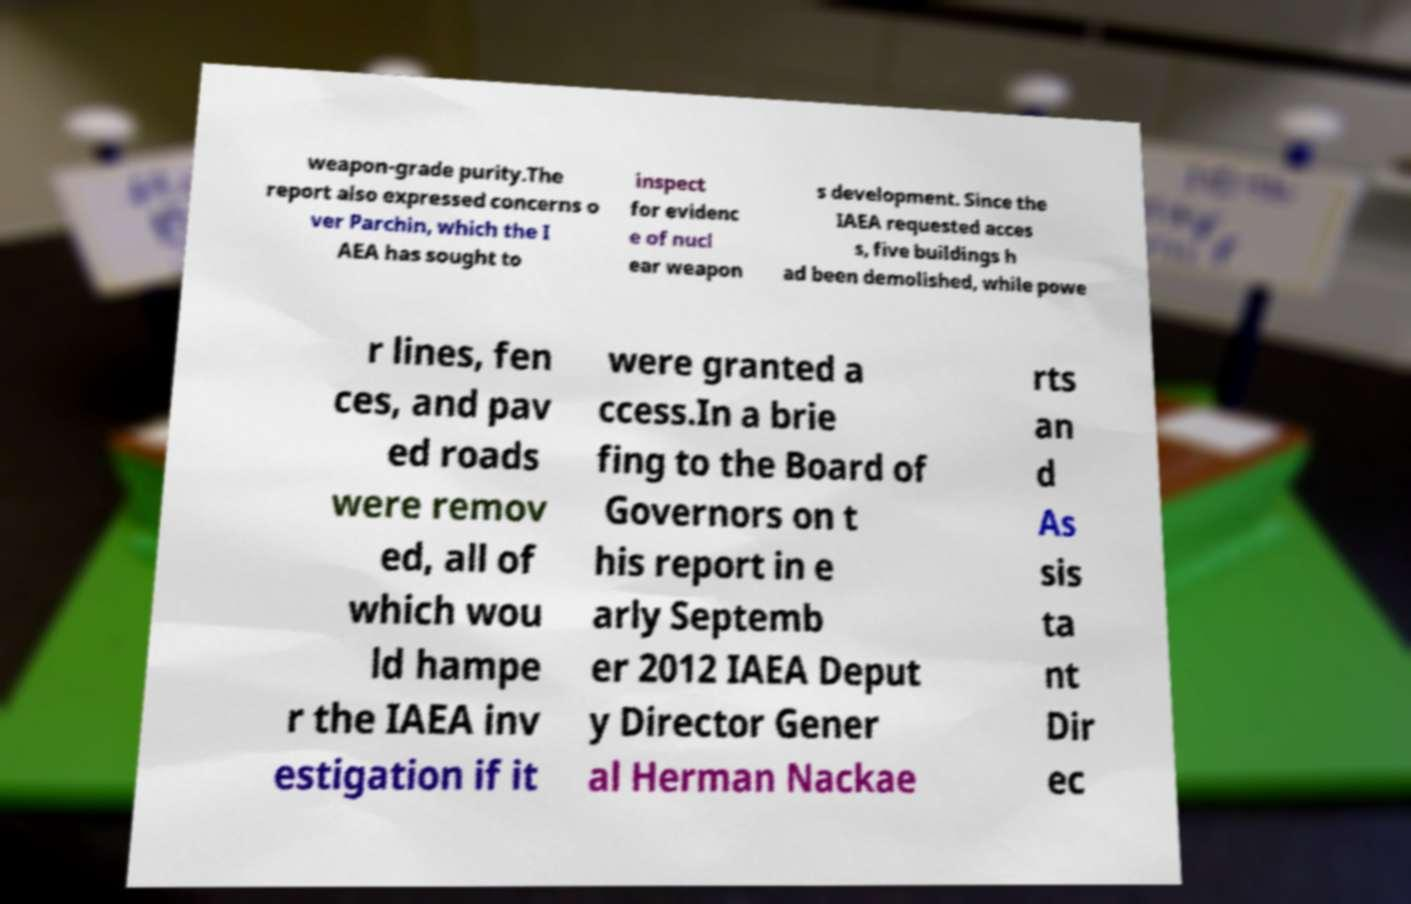Could you assist in decoding the text presented in this image and type it out clearly? weapon-grade purity.The report also expressed concerns o ver Parchin, which the I AEA has sought to inspect for evidenc e of nucl ear weapon s development. Since the IAEA requested acces s, five buildings h ad been demolished, while powe r lines, fen ces, and pav ed roads were remov ed, all of which wou ld hampe r the IAEA inv estigation if it were granted a ccess.In a brie fing to the Board of Governors on t his report in e arly Septemb er 2012 IAEA Deput y Director Gener al Herman Nackae rts an d As sis ta nt Dir ec 